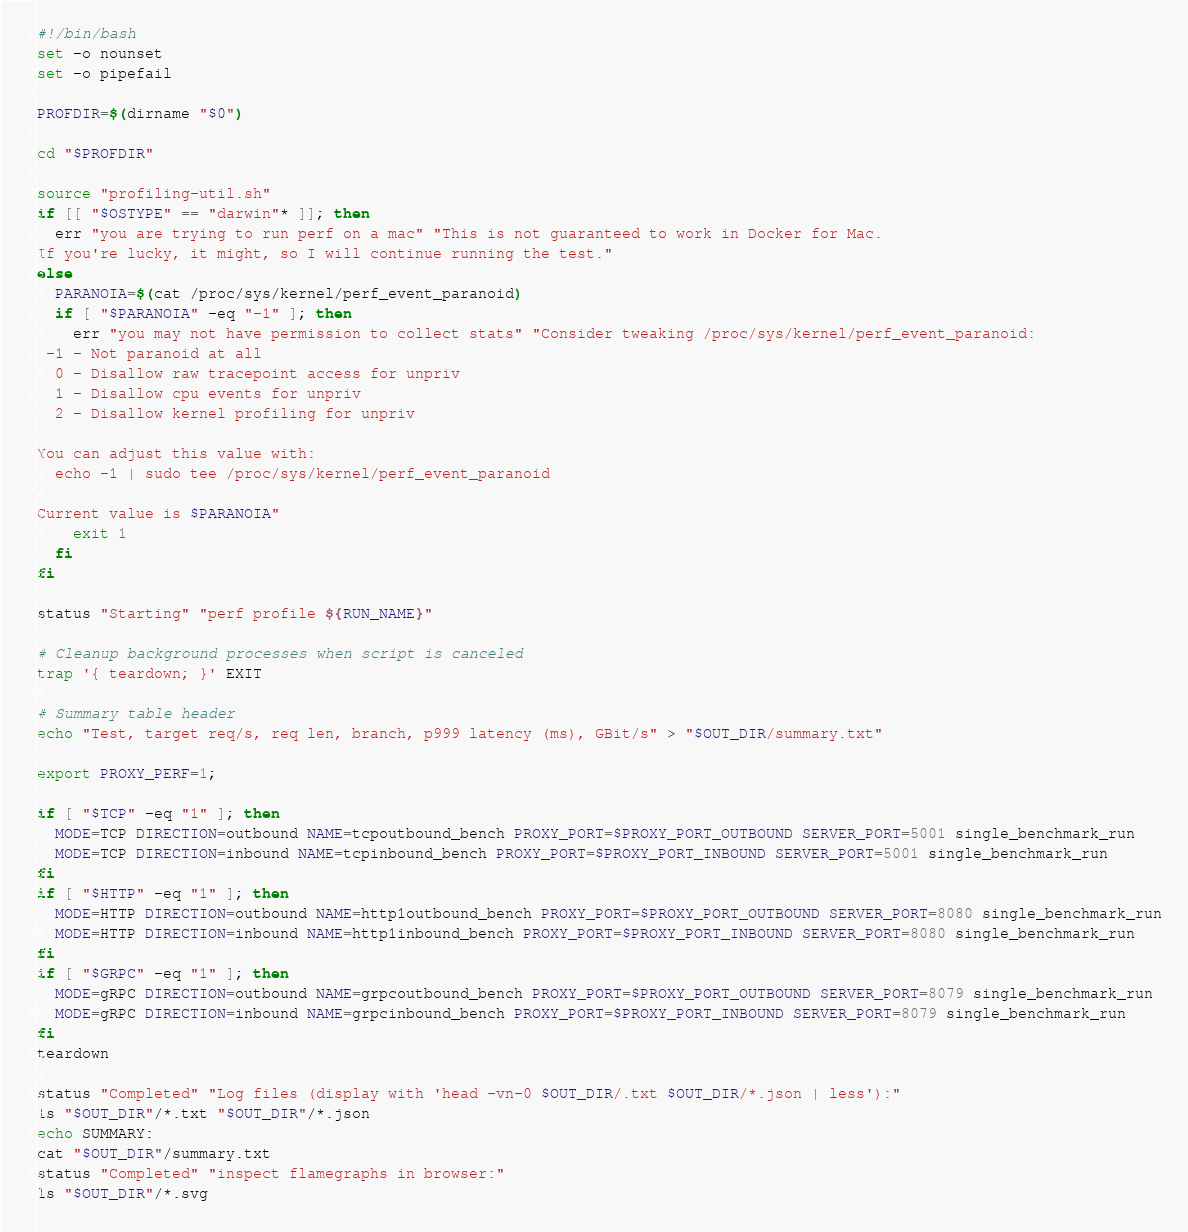Convert code to text. <code><loc_0><loc_0><loc_500><loc_500><_Bash_>#!/bin/bash
set -o nounset
set -o pipefail

PROFDIR=$(dirname "$0")

cd "$PROFDIR"

source "profiling-util.sh"
if [[ "$OSTYPE" == "darwin"* ]]; then
  err "you are trying to run perf on a mac" "This is not guaranteed to work in Docker for Mac.
If you're lucky, it might, so I will continue running the test."
else
  PARANOIA=$(cat /proc/sys/kernel/perf_event_paranoid)
  if [ "$PARANOIA" -eq "-1" ]; then
    err "you may not have permission to collect stats" "Consider tweaking /proc/sys/kernel/perf_event_paranoid:
 -1 - Not paranoid at all
  0 - Disallow raw tracepoint access for unpriv
  1 - Disallow cpu events for unpriv
  2 - Disallow kernel profiling for unpriv

You can adjust this value with:
  echo -1 | sudo tee /proc/sys/kernel/perf_event_paranoid

Current value is $PARANOIA"
    exit 1
  fi
fi

status "Starting" "perf profile ${RUN_NAME}"

# Cleanup background processes when script is canceled
trap '{ teardown; }' EXIT

# Summary table header
echo "Test, target req/s, req len, branch, p999 latency (ms), GBit/s" > "$OUT_DIR/summary.txt"

export PROXY_PERF=1;

if [ "$TCP" -eq "1" ]; then
  MODE=TCP DIRECTION=outbound NAME=tcpoutbound_bench PROXY_PORT=$PROXY_PORT_OUTBOUND SERVER_PORT=5001 single_benchmark_run
  MODE=TCP DIRECTION=inbound NAME=tcpinbound_bench PROXY_PORT=$PROXY_PORT_INBOUND SERVER_PORT=5001 single_benchmark_run
fi
if [ "$HTTP" -eq "1" ]; then
  MODE=HTTP DIRECTION=outbound NAME=http1outbound_bench PROXY_PORT=$PROXY_PORT_OUTBOUND SERVER_PORT=8080 single_benchmark_run
  MODE=HTTP DIRECTION=inbound NAME=http1inbound_bench PROXY_PORT=$PROXY_PORT_INBOUND SERVER_PORT=8080 single_benchmark_run
fi
if [ "$GRPC" -eq "1" ]; then
  MODE=gRPC DIRECTION=outbound NAME=grpcoutbound_bench PROXY_PORT=$PROXY_PORT_OUTBOUND SERVER_PORT=8079 single_benchmark_run
  MODE=gRPC DIRECTION=inbound NAME=grpcinbound_bench PROXY_PORT=$PROXY_PORT_INBOUND SERVER_PORT=8079 single_benchmark_run
fi
teardown

status "Completed" "Log files (display with 'head -vn-0 $OUT_DIR/.txt $OUT_DIR/*.json | less'):"
ls "$OUT_DIR"/*.txt "$OUT_DIR"/*.json
echo SUMMARY:
cat "$OUT_DIR"/summary.txt
status "Completed" "inspect flamegraphs in browser:"
ls "$OUT_DIR"/*.svg

</code> 